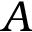Convert formula to latex. <formula><loc_0><loc_0><loc_500><loc_500>A</formula> 